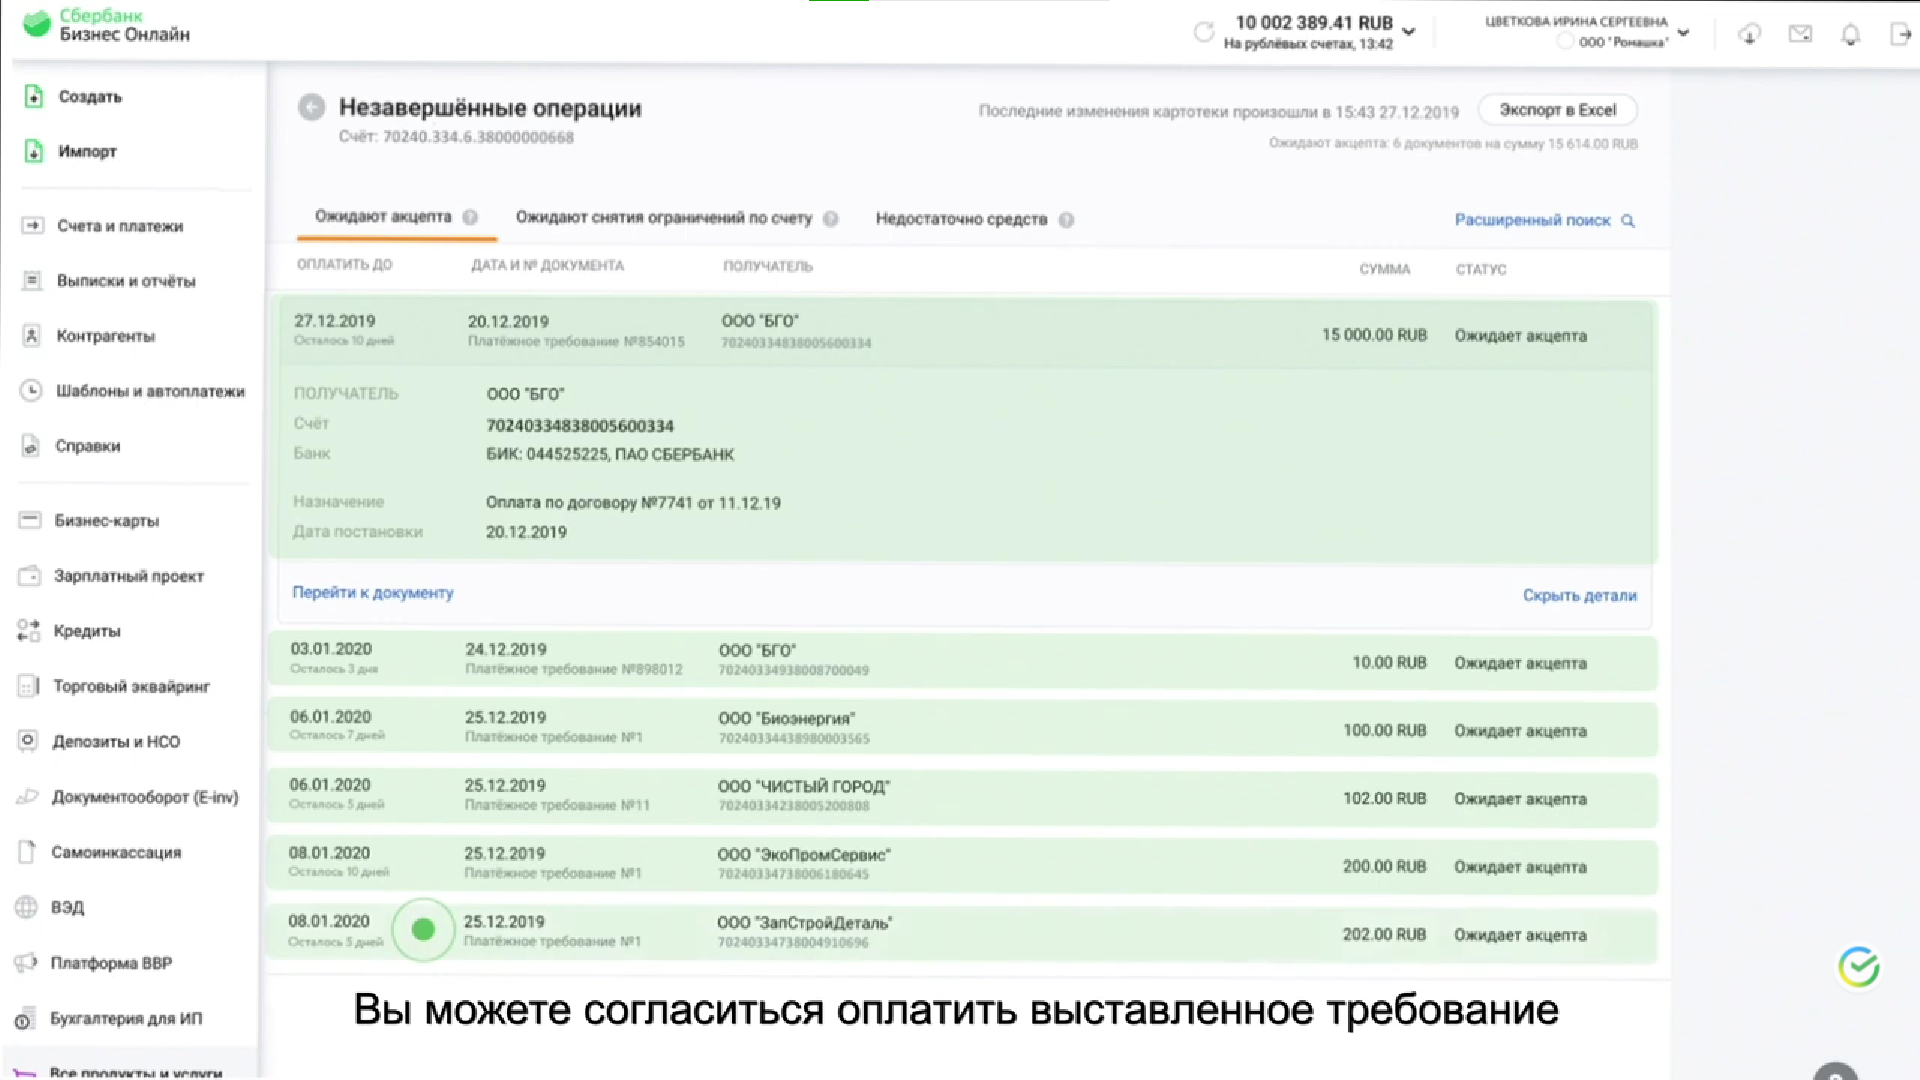Перечисли получателей незавершенных операций Получатели незавершенных операций:
* ООО "БГТО"
* ООО "Биоэнергия"
* ООО "Чистый город"
* ООО "ЭкоПрофСервис"
* ООО "Занстройдеталь" 